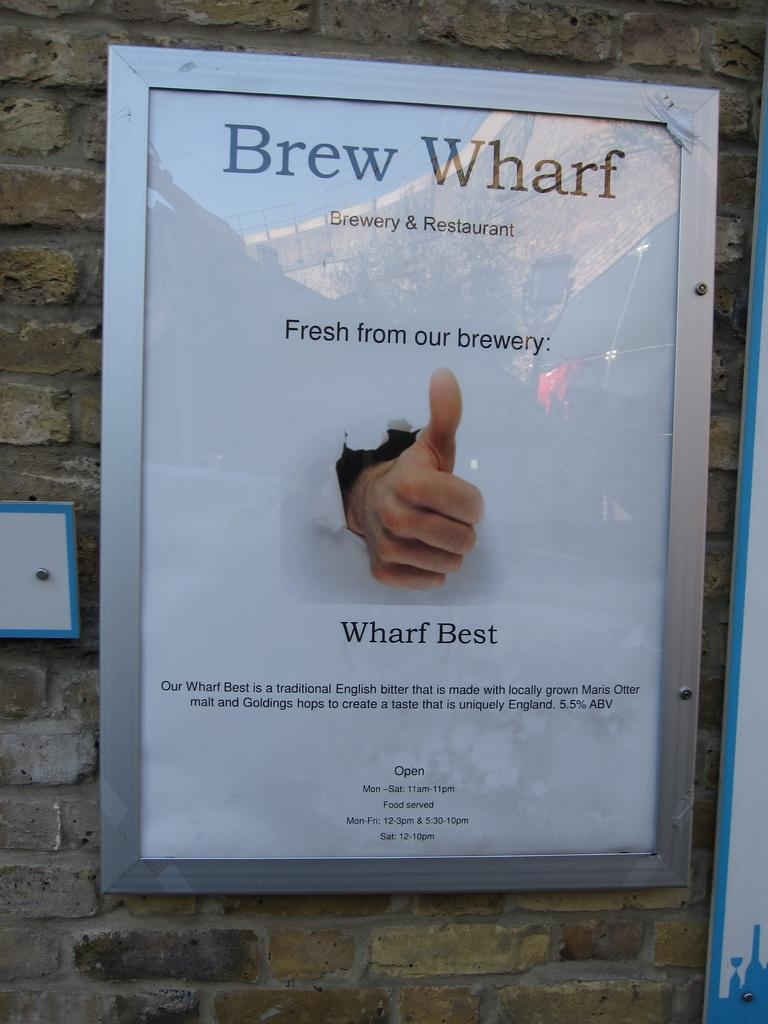What is attached to the wall in the image? There are boards on the wall in the image. Can you describe the person's hand that is visible in the image? A person's hand is visible on one of the boards. What type of coach can be seen in the image? There is no coach present in the image; it only features boards on the wall and a person's hand. What kind of drum is being played in the image? There is no drum present in the image; it only features boards on the wall and a person's hand. 